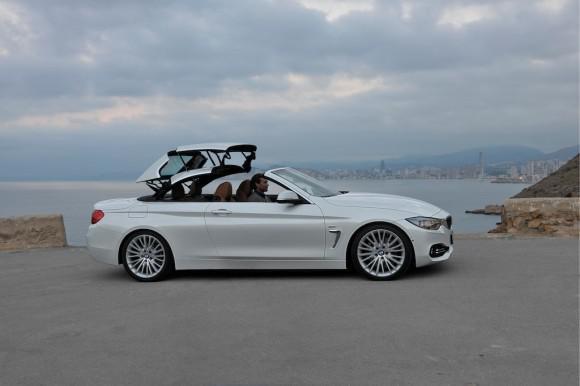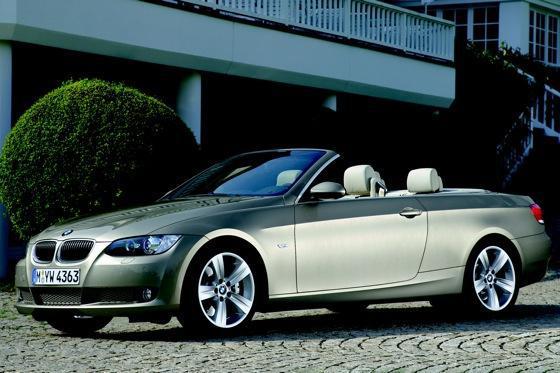The first image is the image on the left, the second image is the image on the right. Assess this claim about the two images: "Right image contains one blue car, which has a hard top.". Correct or not? Answer yes or no. No. The first image is the image on the left, the second image is the image on the right. Considering the images on both sides, is "In the image on the right, there is a blue car without the top down" valid? Answer yes or no. No. 